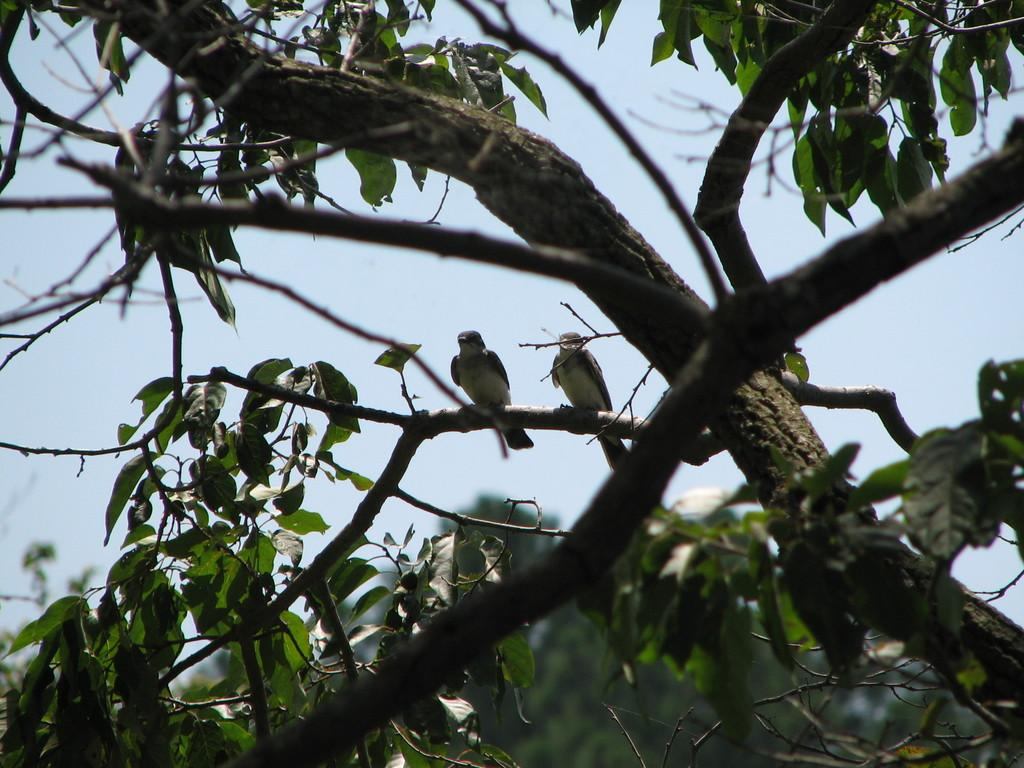What type of vegetation can be seen in the image? There are trees in the image. Are there any animals present in the image? Yes, there are birds on one of the trees. What part of the natural environment is visible in the image? The sky is visible in the image. What type of offer is the giant making to the birds in the image? There are no giants present in the image, so it is not possible to answer that question. 